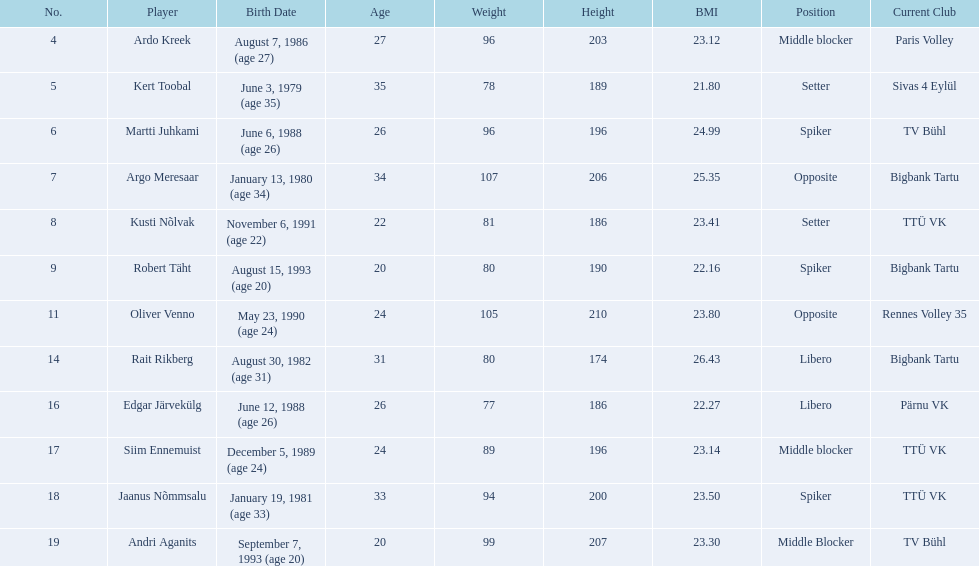Who is the tallest member of estonia's men's national volleyball team? Oliver Venno. 